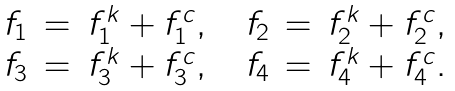<formula> <loc_0><loc_0><loc_500><loc_500>\begin{array} { r c l } f _ { 1 } & = & f _ { 1 } ^ { k } + f _ { 1 } ^ { c } , \quad f _ { 2 } \, = \, f _ { 2 } ^ { k } + f _ { 2 } ^ { c } , \\ f _ { 3 } & = & f _ { 3 } ^ { k } + f _ { 3 } ^ { c } , \quad f _ { 4 } \, = \, f _ { 4 } ^ { k } + f _ { 4 } ^ { c } . \end{array}</formula> 